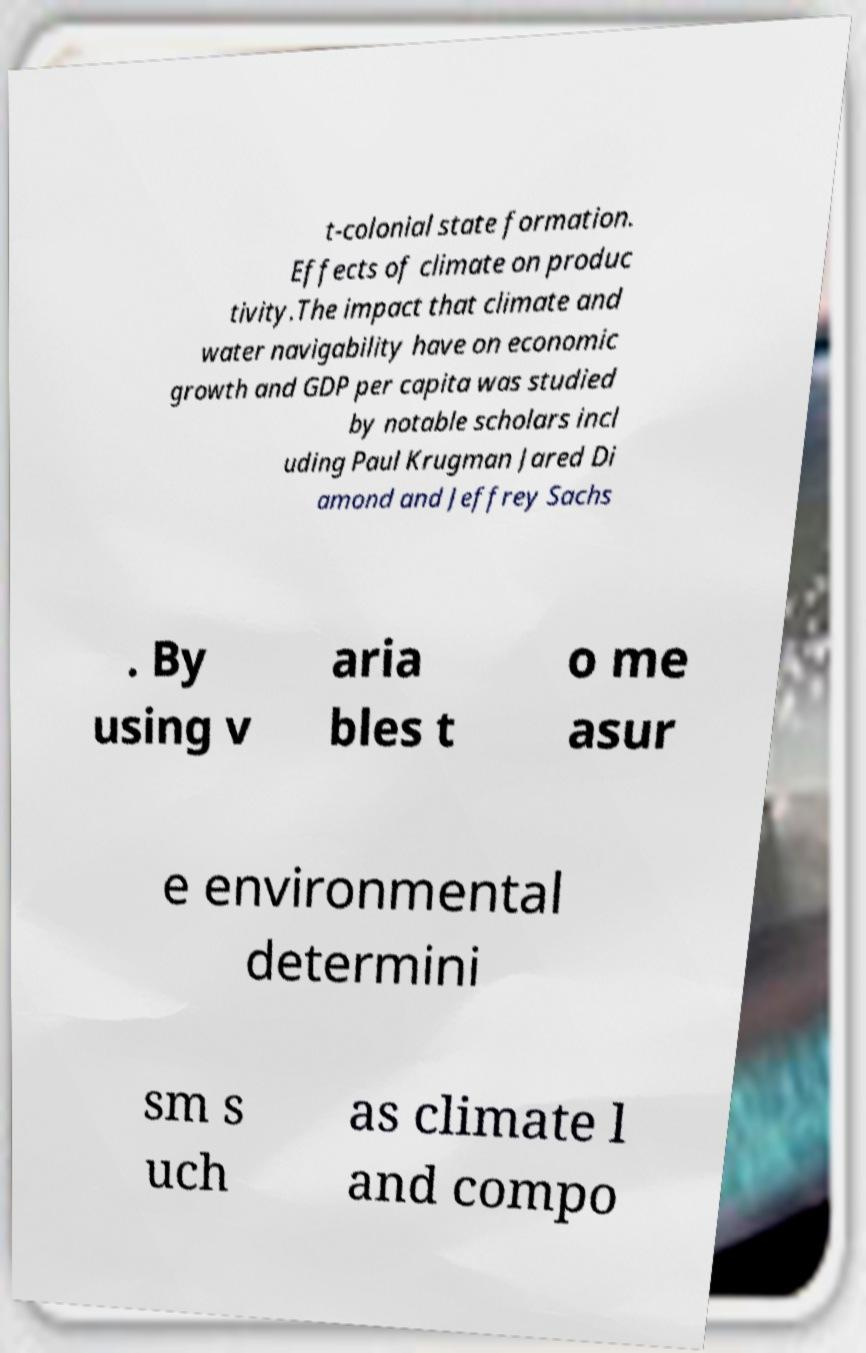What messages or text are displayed in this image? I need them in a readable, typed format. t-colonial state formation. Effects of climate on produc tivity.The impact that climate and water navigability have on economic growth and GDP per capita was studied by notable scholars incl uding Paul Krugman Jared Di amond and Jeffrey Sachs . By using v aria bles t o me asur e environmental determini sm s uch as climate l and compo 